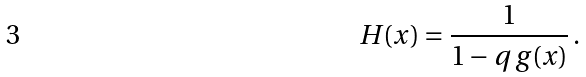<formula> <loc_0><loc_0><loc_500><loc_500>H ( x ) = \frac { 1 } { 1 - q \, g ( x ) } \, .</formula> 